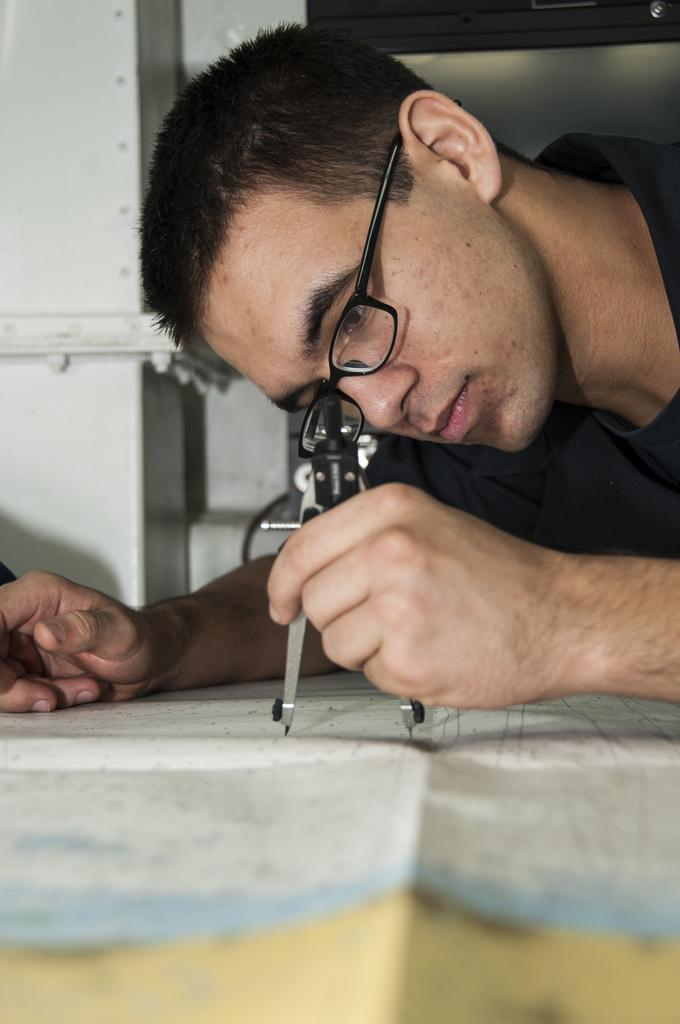Who is present in the image? There is a man in the image. What is the man holding in the image? The man is holding a compass. What accessory is the man wearing in the image? The man is wearing spectacles. What else can be seen in the image besides the man? There is a paper in the image. What can be seen in the background of the image? There is a pillar in the background of the image. What type of bushes can be seen burning in the image? There are no bushes or flames present in the image. 